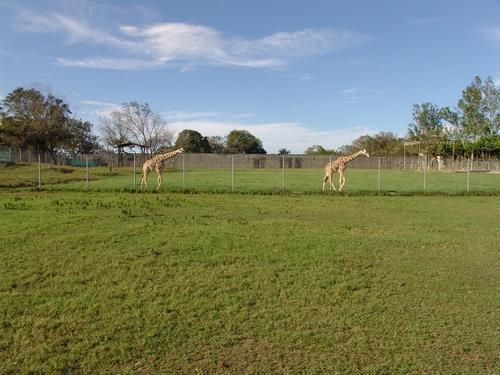How many zebras are babies?
Give a very brief answer. 0. How many species of animal are shown?
Give a very brief answer. 1. 